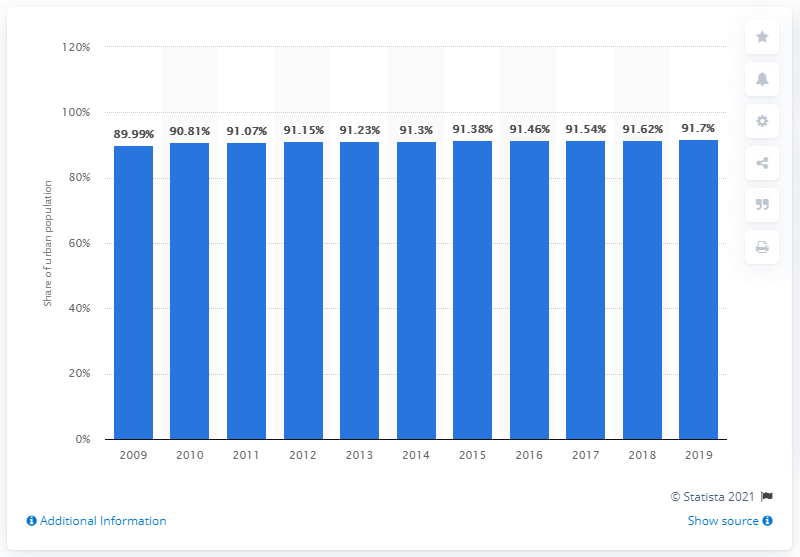Specify some key components in this picture. In the past decade, the level of urbanization in Japan has been 91.7%. 